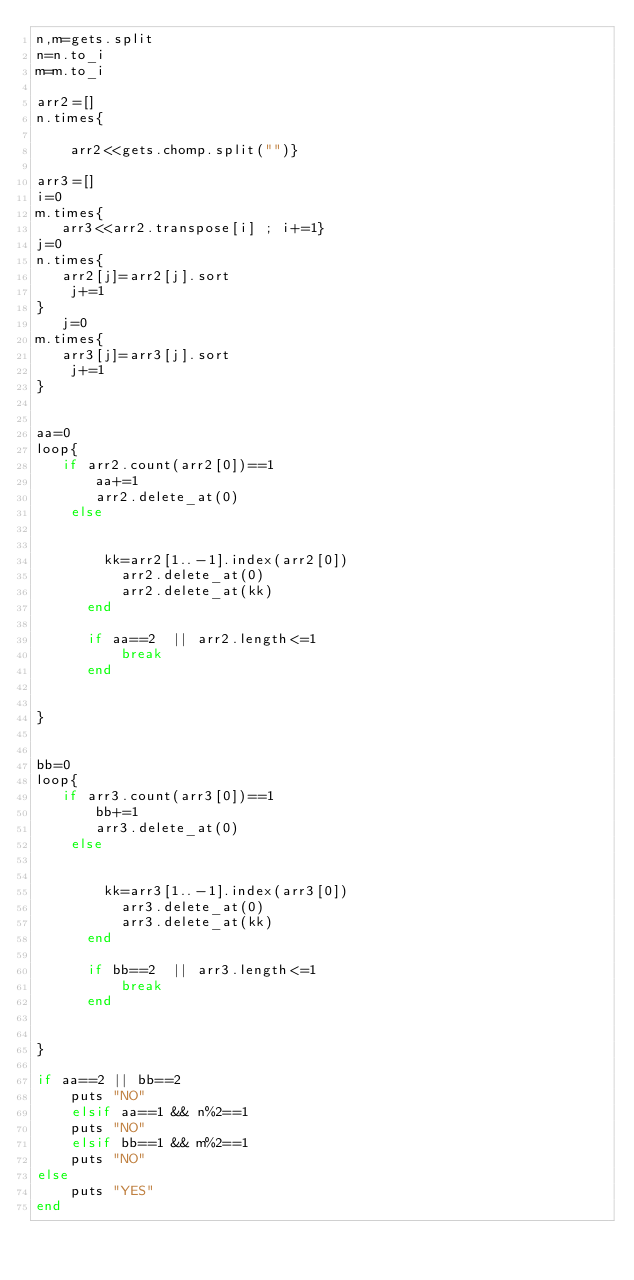Convert code to text. <code><loc_0><loc_0><loc_500><loc_500><_Ruby_>n,m=gets.split
n=n.to_i
m=m.to_i

arr2=[]
n.times{
    
    arr2<<gets.chomp.split("")}
    
arr3=[]
i=0
m.times{
   arr3<<arr2.transpose[i] ; i+=1}
j=0
n.times{
   arr2[j]=arr2[j].sort
    j+=1
}
   j=0
m.times{
   arr3[j]=arr3[j].sort
    j+=1
}


aa=0
loop{
   if arr2.count(arr2[0])==1
       aa+=1
       arr2.delete_at(0)
    else 
        
      
        kk=arr2[1..-1].index(arr2[0])
          arr2.delete_at(0)
          arr2.delete_at(kk)
      end
      
      if aa==2  || arr2.length<=1
          break
      end
          
    
}


bb=0
loop{
   if arr3.count(arr3[0])==1
       bb+=1
       arr3.delete_at(0)
    else 
        
      
        kk=arr3[1..-1].index(arr3[0])
          arr3.delete_at(0)
          arr3.delete_at(kk)
      end
      
      if bb==2  || arr3.length<=1
          break
      end
          
    
}

if aa==2 || bb==2
    puts "NO"
    elsif aa==1 && n%2==1
    puts "NO"
    elsif bb==1 && m%2==1
    puts "NO"
else 
    puts "YES"
end
</code> 